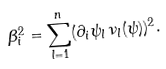<formula> <loc_0><loc_0><loc_500><loc_500>\beta _ { i } ^ { 2 } = \sum _ { l = 1 } ^ { n } ( \partial _ { i } \psi _ { l } \, \nu _ { l } ( \psi ) ) ^ { 2 } .</formula> 